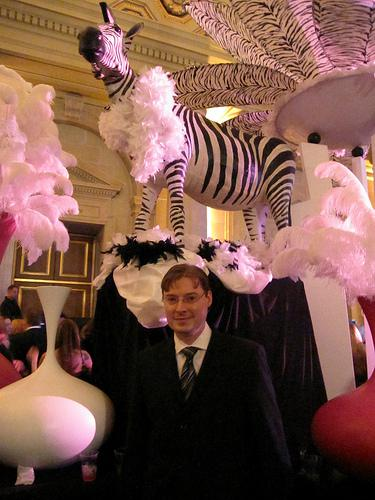Question: why is he happy?
Choices:
A. It is his birthday.
B. He Is in a costume shop.
C. His child was born.
D. He got a present.
Answer with the letter. Answer: B Question: what colors are the zebra?
Choices:
A. Brown and gray.
B. Blue and pink.
C. Black and white.
D. Red and green.
Answer with the letter. Answer: C Question: how many zebras are there?
Choices:
A. Two.
B. One.
C. Three.
D. Four.
Answer with the letter. Answer: B Question: where is the zebra?
Choices:
A. In the field.
B. In the zoo.
C. In the wild.
D. Above the man's head.
Answer with the letter. Answer: D Question: what is the man wearing on his face?
Choices:
A. Makeup.
B. Mask.
C. Sun lotion.
D. Glasses.
Answer with the letter. Answer: D 